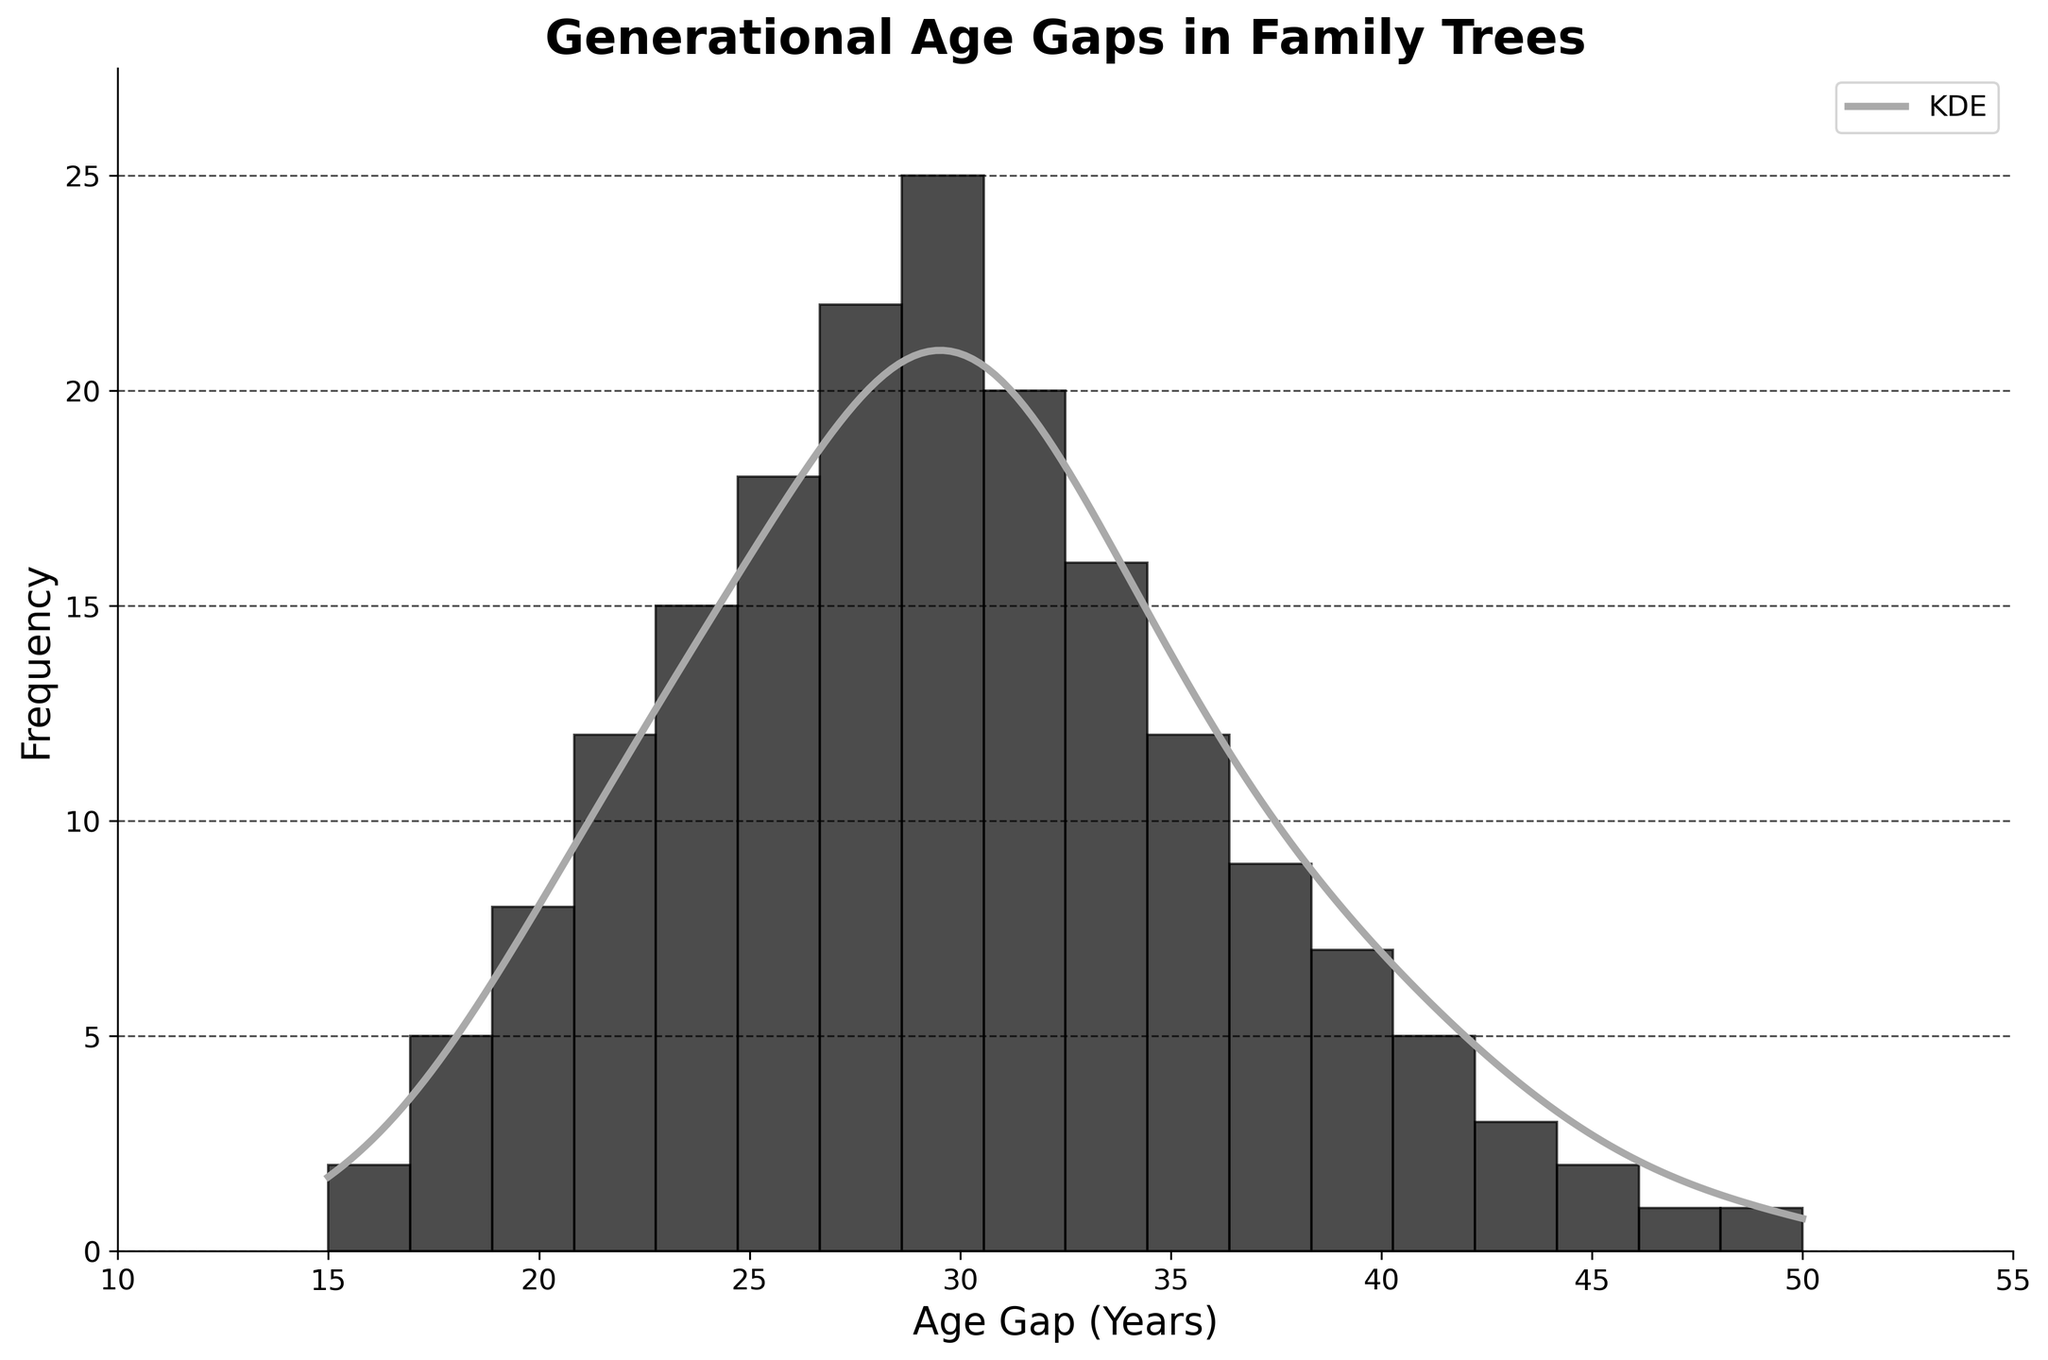What is the title of the figure? The title is indicated at the top of the figure, which reads 'Generational Age Gaps in Family Trees'.
Answer: 'Generational Age Gaps in Family Trees' What is the range of age gaps displayed on the x-axis? The x-axis, labeled as 'Age Gap (Years)', shows the range from 10 to 55 years.
Answer: 10 to 55 years At what age gap is the highest frequency observed? By looking at the histogram bars, the highest frequency is observed at the 30-year age gap with a frequency of 25.
Answer: 30 years Approximately, where is the peak of the KDE (density curve) located? The KDE peak can be identified by locating the highest point on the density curve. It appears to be around the 30-year mark.
Answer: Around 30 years How many age gaps have a frequency greater than 20? Referring to the histogram bars, the age gaps with frequencies greater than 20 are 28 and 30 years. This can be counted as 2 age gaps.
Answer: 2 age gaps Is the frequency at the 24-year age gap greater or smaller than that at the 34-year age gap? The histogram shows a frequency slightly greater for the 24-year age gap (15) compared to the 34-year age gap (16).
Answer: Smaller What can you say about the skewness of the histogram and the KDE curve? Observing the shape of both the histogram and KDE curve, it can be seen that they appear symmetric around the peak at 30 years, indicating little to no skewness.
Answer: Symmetric (little to no skewness) What is the frequency range covered by the y-axis? The y-axis, labeled 'Frequency', ranges from 0 to a bit above 25, with the maximum frequency bar (30 years) reaching 25.
Answer: 0 to just above 25 What is the trend in frequencies as the age gap increases from 15 to 50 years? Initially, as the age gap increases from 15 to around 30 years, the frequency increases, peaking at 30 years. Beyond 30 years, the frequency generally decreases as the age gap increases to 50 years.
Answer: Increases to 30 years, then decreases to 50 years How does the frequency at 20 years compare to that at 40 years? By comparing histogram bars, the frequency at 20 years (8) is higher than that at 40 years (7).
Answer: Higher at 20 years 